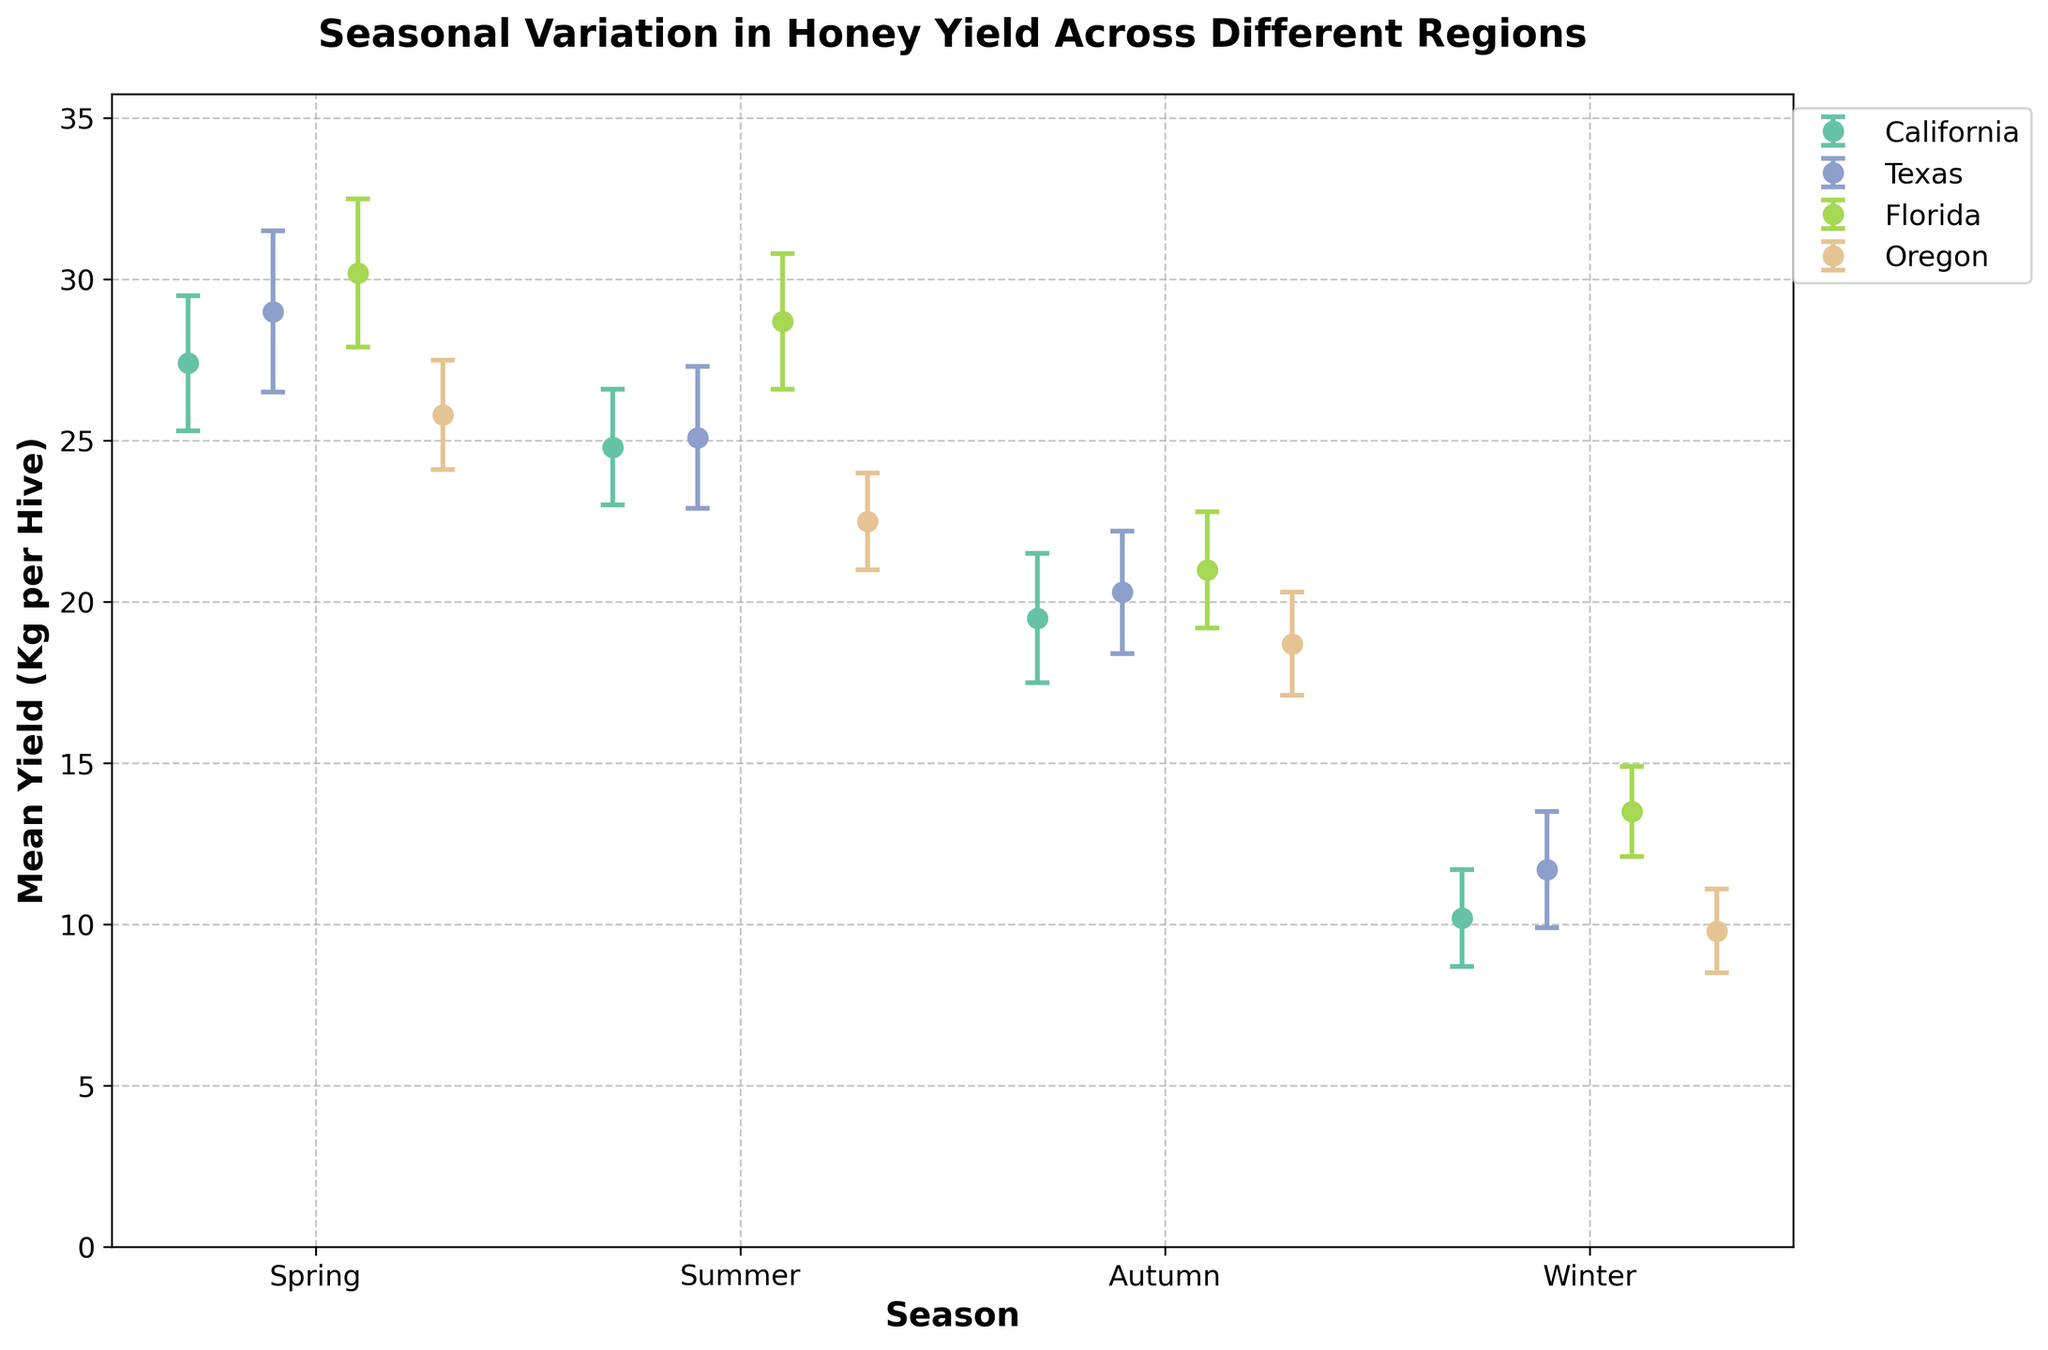What is the title of the plot? The title appears at the top of the figure and provides a summary of the content. It is helpful for quickly understanding the topic of the plot.
Answer: Seasonal Variation in Honey Yield Across Different Regions What does the x-axis represent? The x-axis labels are located at the bottom of the plot, and they represent the different seasons for which the honey yields are plotted.
Answer: Season Which region has the highest mean yield in Spring? Look at the data points for Spring and find the one with the highest value. The data point for Florida in Spring is highest at 30.2 Kg per hive.
Answer: Florida What is the mean yield for Winter in Texas? Locate the data point labeled as Texas in Winter, the Y-axis indicates the mean yield value.
Answer: 11.7 Kg per hive What is the difference in mean yield between Spring and Winter in Florida? Locate the mean yield for Florida in both Spring and Winter, then compute the difference (30.2 - 13.5).
Answer: 16.7 Kg per hive Which two regions have overlapping error bars in Summer? Look at the error bars for each region during Summer and identify any overlapping segments. The error bars for California and Texas in Summer overlap.
Answer: California and Texas Which season has the smallest overall honey yield across all regions? Compare the mean yields for all regions across each season. Winter generally has the smallest yield.
Answer: Winter What season has the largest error margin for the mean yield in Texas? Look at the error margin data points for each season in Texas, and find the one with the largest value (2.5 Kg in Spring).
Answer: Spring In which region does the mean yield decrease the most from Spring to Autumn? Compare the decrease (Spring yield - Autumn yield) for each region and identify the largest value. The decrease in Florida is the highest (30.2 - 21.0 = 9.2 Kg).
Answer: Florida Which region shows the most consistent mean yield across all seasons with respect to error margins? Assess the error bars and mean yields for each region to identify which has the least fluctuation. Oregon has the most consistent mean yield with relatively smaller error margins across the seasons.
Answer: Oregon 